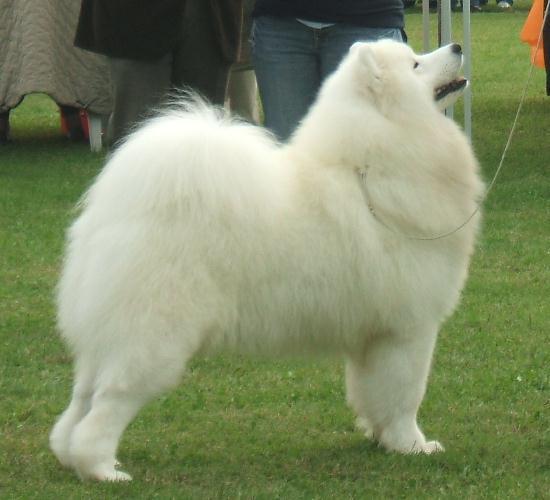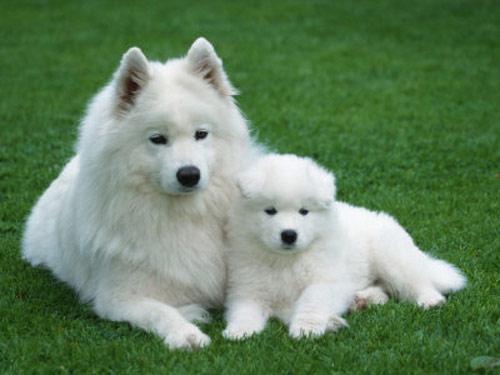The first image is the image on the left, the second image is the image on the right. Assess this claim about the two images: "An adult dog is lying down next to a puppy.". Correct or not? Answer yes or no. Yes. 